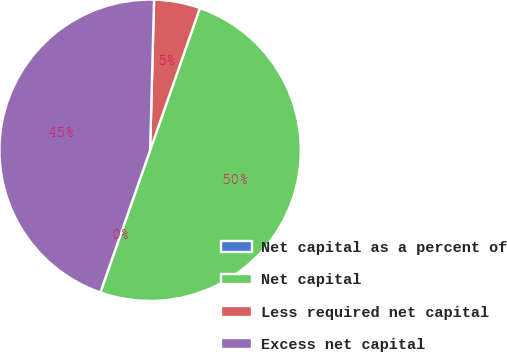Convert chart. <chart><loc_0><loc_0><loc_500><loc_500><pie_chart><fcel>Net capital as a percent of<fcel>Net capital<fcel>Less required net capital<fcel>Excess net capital<nl><fcel>0.0%<fcel>50.0%<fcel>4.94%<fcel>45.06%<nl></chart> 